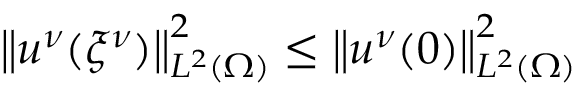Convert formula to latex. <formula><loc_0><loc_0><loc_500><loc_500>\left \| u ^ { \nu } ( { \xi ^ { \nu } } ) \right \| _ { L ^ { 2 } ( \Omega ) } ^ { 2 } \leq \left \| u ^ { \nu } ( 0 ) \right \| _ { L ^ { 2 } ( \Omega ) } ^ { 2 }</formula> 